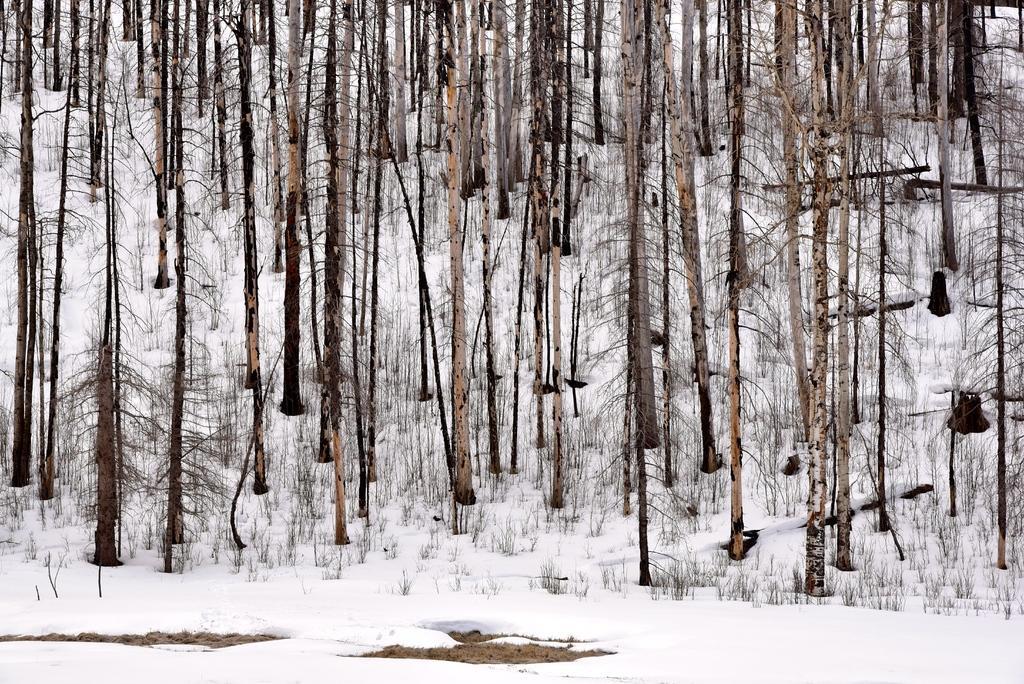How would you summarize this image in a sentence or two? In this image there are few tree trunks with some grass are on the land which is covered with snow. 